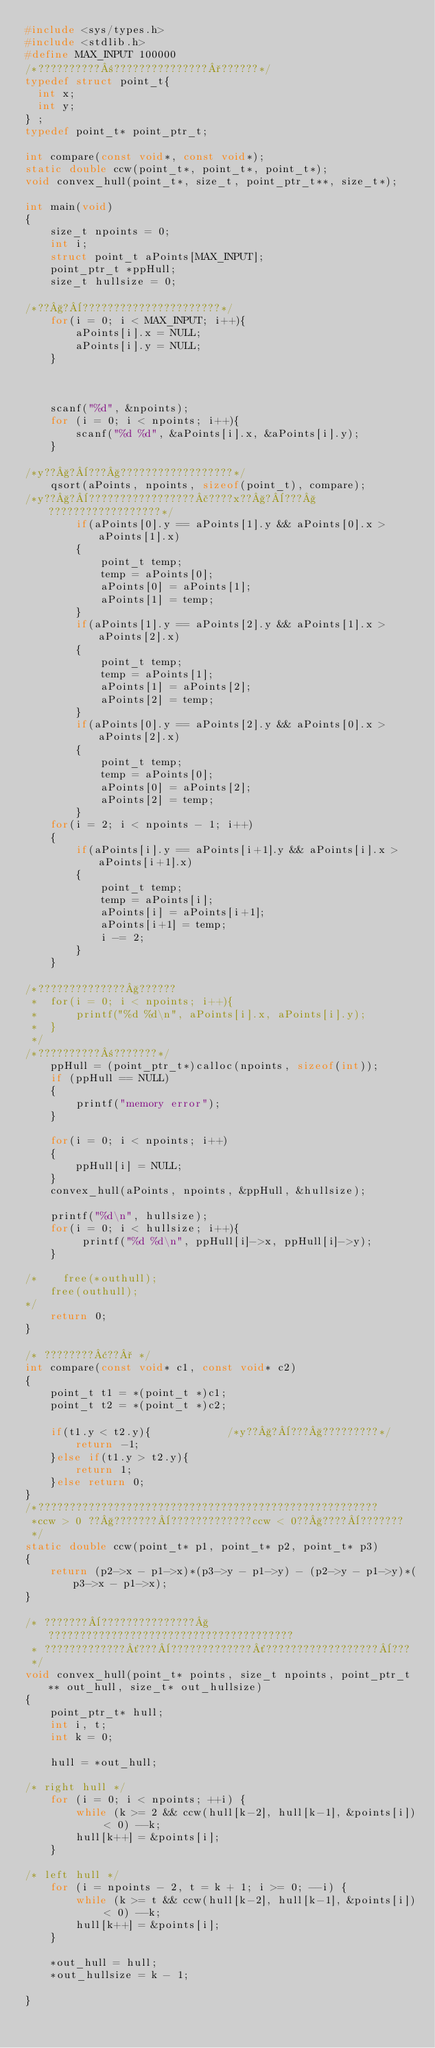<code> <loc_0><loc_0><loc_500><loc_500><_C_>#include <sys/types.h>
#include <stdlib.h>
#define MAX_INPUT 100000
/*??????????±???????????????°??????*/
typedef struct point_t{
  int x;
  int y;
} ;
typedef point_t* point_ptr_t;

int compare(const void*, const void*);
static double ccw(point_t*, point_t*, point_t*);
void convex_hull(point_t*, size_t, point_ptr_t**, size_t*);

int main(void)
{
    size_t npoints = 0; 
    int i;
    struct point_t aPoints[MAX_INPUT];
    point_ptr_t *ppHull;
    size_t hullsize = 0;

/*??§?¨??????????????????????*/
    for(i = 0; i < MAX_INPUT; i++){
        aPoints[i].x = NULL;
        aPoints[i].y = NULL;
    }



    scanf("%d", &npoints);
    for (i = 0; i < npoints; i++){
        scanf("%d %d", &aPoints[i].x, &aPoints[i].y);
    }

/*y??§?¨???§??????????????????*/
    qsort(aPoints, npoints, sizeof(point_t), compare);
/*y??§?¨?????????????????£????x??§?¨???§??????????????????*/
        if(aPoints[0].y == aPoints[1].y && aPoints[0].x > aPoints[1].x)
        {
            point_t temp;
            temp = aPoints[0];
            aPoints[0] = aPoints[1];
            aPoints[1] = temp;
        }
        if(aPoints[1].y == aPoints[2].y && aPoints[1].x > aPoints[2].x)
        {
            point_t temp;
            temp = aPoints[1];
            aPoints[1] = aPoints[2];
            aPoints[2] = temp;
        }
        if(aPoints[0].y == aPoints[2].y && aPoints[0].x > aPoints[2].x)
        {
            point_t temp;
            temp = aPoints[0];
            aPoints[0] = aPoints[2];
            aPoints[2] = temp;
        }
    for(i = 2; i < npoints - 1; i++)
    {
        if(aPoints[i].y == aPoints[i+1].y && aPoints[i].x > aPoints[i+1].x)
        {
            point_t temp;
            temp = aPoints[i];
            aPoints[i] = aPoints[i+1];
            aPoints[i+1] = temp;
            i -= 2;
        }
    }    

/*??????????????§??????
 *  for(i = 0; i < npoints; i++){
 *      printf("%d %d\n", aPoints[i].x, aPoints[i].y);
 *  }
 */
/*??????????±???????*/
    ppHull = (point_ptr_t*)calloc(npoints, sizeof(int));
    if (ppHull == NULL)
    {
        printf("memory error");
    }

    for(i = 0; i < npoints; i++)
    {
        ppHull[i] = NULL;
    }
    convex_hull(aPoints, npoints, &ppHull, &hullsize);

    printf("%d\n", hullsize);
    for(i = 0; i < hullsize; i++){
         printf("%d %d\n", ppHull[i]->x, ppHull[i]->y);
    }

/*    free(*outhull);
    free(outhull);
*/
    return 0;
}

/* ????????¢??° */
int compare(const void* c1, const void* c2)
{
    point_t t1 = *(point_t *)c1;
    point_t t2 = *(point_t *)c2;

    if(t1.y < t2.y){            /*y??§?¨???§?????????*/
        return -1;
    }else if(t1.y > t2.y){
        return 1;
    }else return 0;
}
/*??????????????????????????????????????????????????????
 *ccw > 0 ??§???????¨?????????????ccw < 0??§????¨???????
 */
static double ccw(point_t* p1, point_t* p2, point_t* p3)
{
    return (p2->x - p1->x)*(p3->y - p1->y) - (p2->y - p1->y)*(p3->x - p1->x);
}

/* ???????¨???????????????§???????????????????????????????????????
 * ?????????????´???¨?????????????´??????????????????¨???
 */
void convex_hull(point_t* points, size_t npoints, point_ptr_t** out_hull, size_t* out_hullsize)
{
    point_ptr_t* hull;
    int i, t;
    int k = 0;

    hull = *out_hull;

/* right hull */
    for (i = 0; i < npoints; ++i) {
        while (k >= 2 && ccw(hull[k-2], hull[k-1], &points[i]) < 0) --k;
        hull[k++] = &points[i];
    }

/* left hull */
    for (i = npoints - 2, t = k + 1; i >= 0; --i) {
        while (k >= t && ccw(hull[k-2], hull[k-1], &points[i]) < 0) --k;
        hull[k++] = &points[i];
    }
  
    *out_hull = hull;
    *out_hullsize = k - 1;

}</code> 